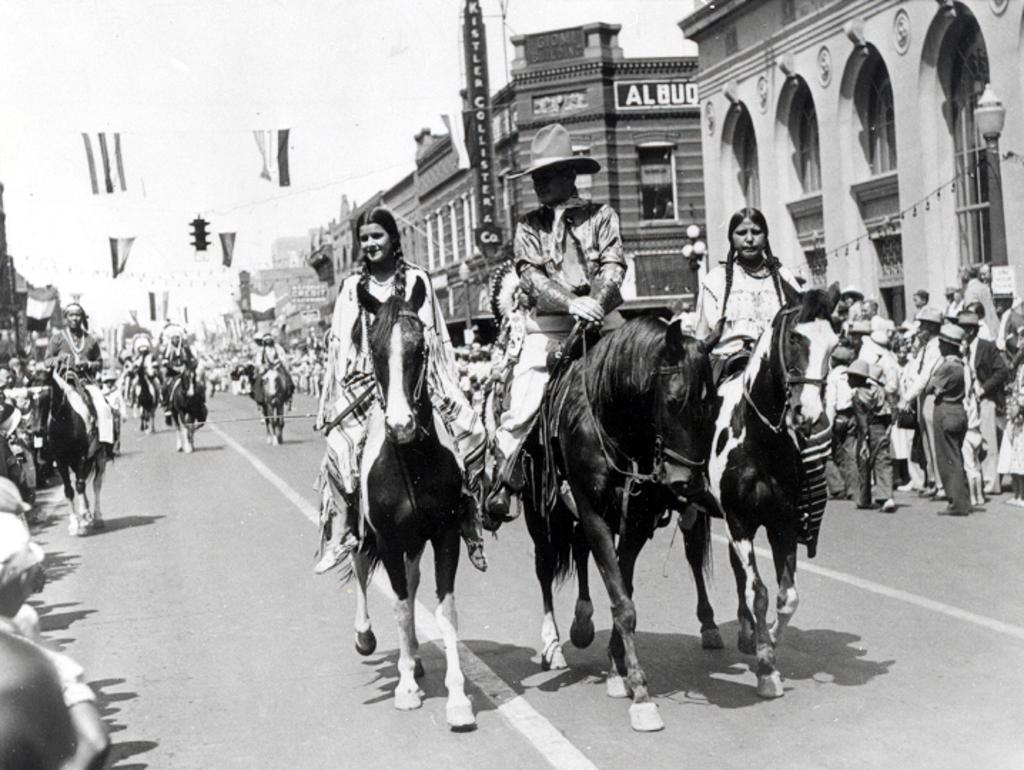What are the people in the image doing? The people in the image are riding horses. What can be seen in the distance behind the people riding horses? There are buildings in the background of the image. What are the people doing near the buildings in the background? There are people standing around the buildings in the background. What type of fish can be seen swimming in the river near the buildings? There is no river or fish present in the image; it features people riding horses and buildings in the background. 